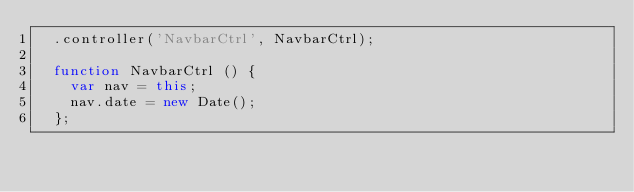Convert code to text. <code><loc_0><loc_0><loc_500><loc_500><_JavaScript_>  .controller('NavbarCtrl', NavbarCtrl);

  function NavbarCtrl () {
  	var nav = this;
    nav.date = new Date();
  };
</code> 